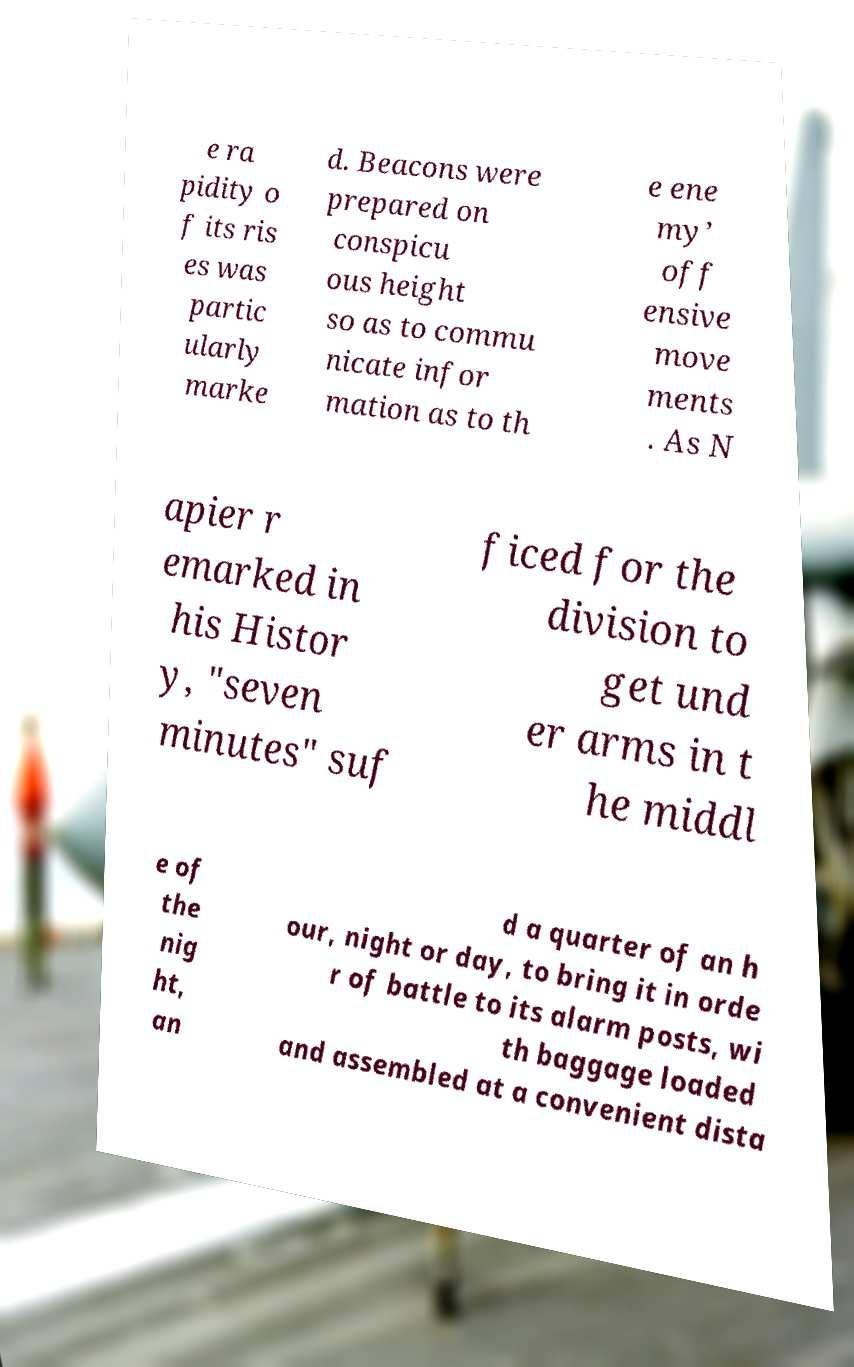For documentation purposes, I need the text within this image transcribed. Could you provide that? e ra pidity o f its ris es was partic ularly marke d. Beacons were prepared on conspicu ous height so as to commu nicate infor mation as to th e ene my’ off ensive move ments . As N apier r emarked in his Histor y, "seven minutes" suf ficed for the division to get und er arms in t he middl e of the nig ht, an d a quarter of an h our, night or day, to bring it in orde r of battle to its alarm posts, wi th baggage loaded and assembled at a convenient dista 